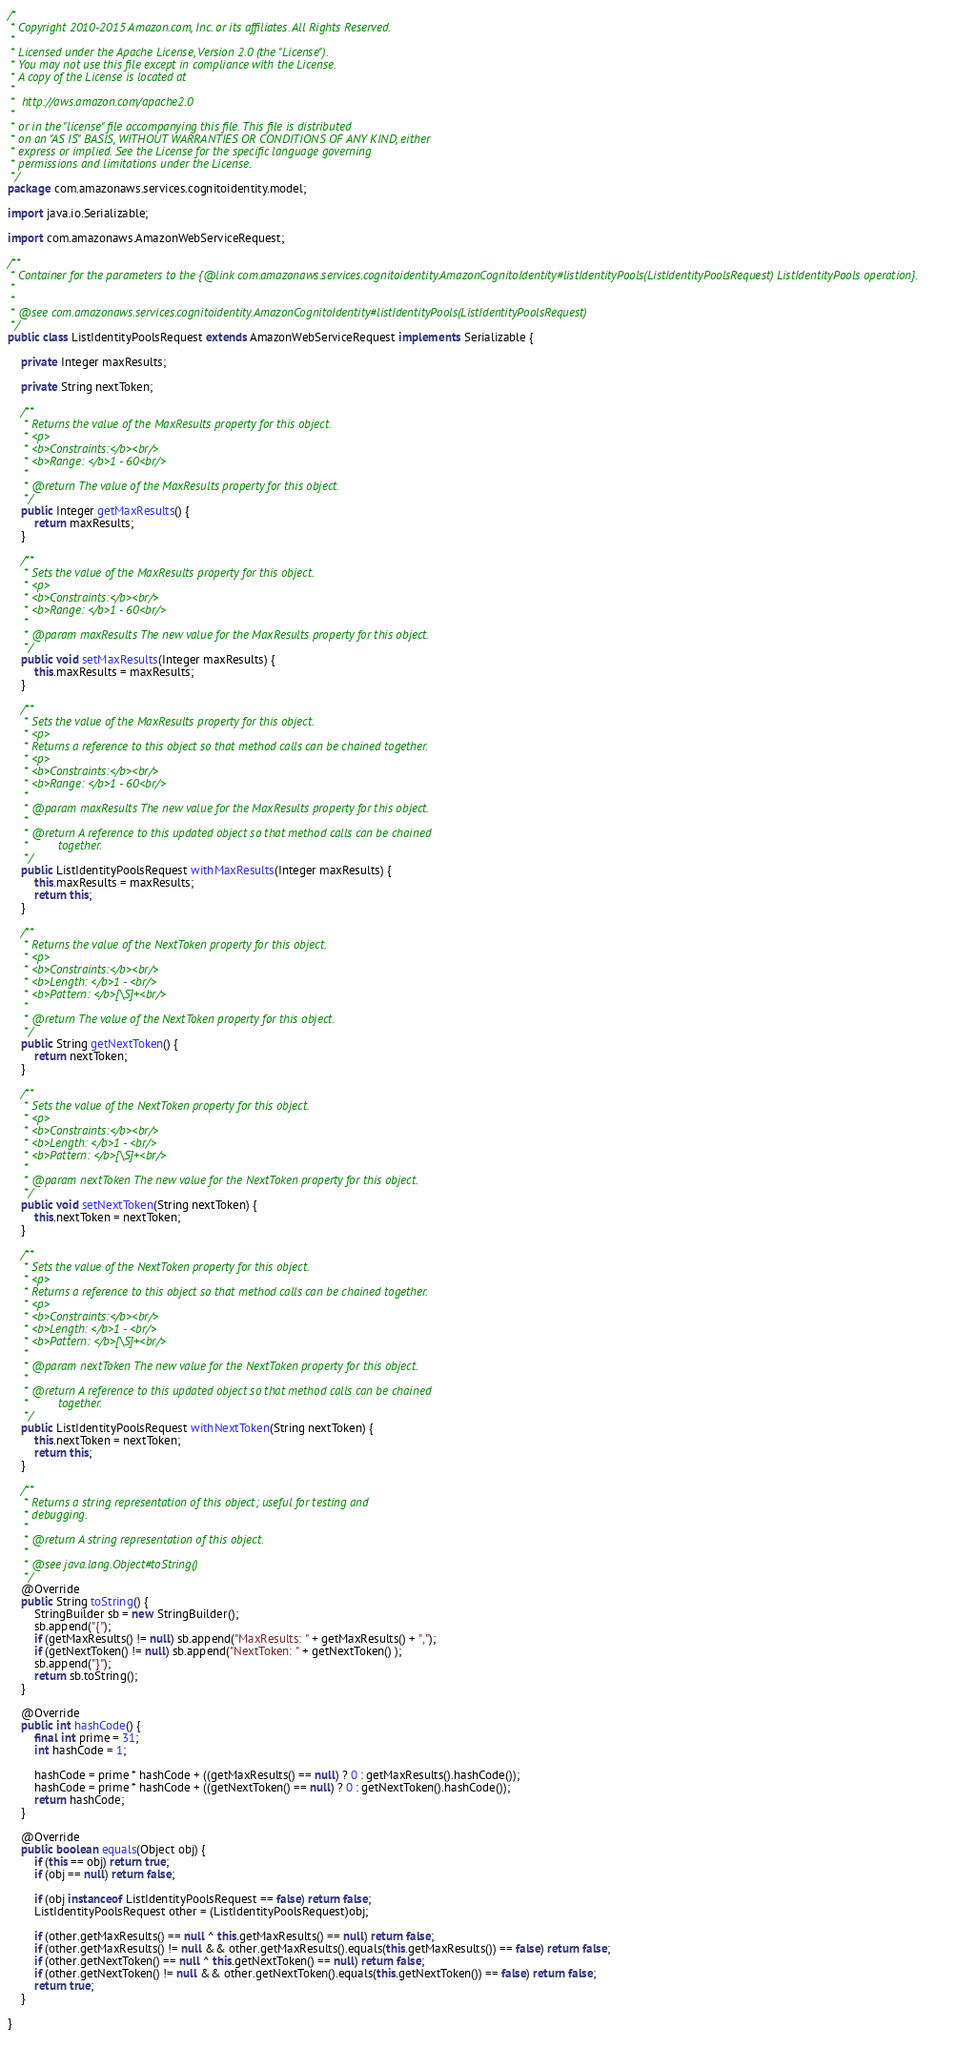Convert code to text. <code><loc_0><loc_0><loc_500><loc_500><_Java_>/*
 * Copyright 2010-2015 Amazon.com, Inc. or its affiliates. All Rights Reserved.
 * 
 * Licensed under the Apache License, Version 2.0 (the "License").
 * You may not use this file except in compliance with the License.
 * A copy of the License is located at
 * 
 *  http://aws.amazon.com/apache2.0
 * 
 * or in the "license" file accompanying this file. This file is distributed
 * on an "AS IS" BASIS, WITHOUT WARRANTIES OR CONDITIONS OF ANY KIND, either
 * express or implied. See the License for the specific language governing
 * permissions and limitations under the License.
 */
package com.amazonaws.services.cognitoidentity.model;

import java.io.Serializable;

import com.amazonaws.AmazonWebServiceRequest;

/**
 * Container for the parameters to the {@link com.amazonaws.services.cognitoidentity.AmazonCognitoIdentity#listIdentityPools(ListIdentityPoolsRequest) ListIdentityPools operation}.
 * 
 *
 * @see com.amazonaws.services.cognitoidentity.AmazonCognitoIdentity#listIdentityPools(ListIdentityPoolsRequest)
 */
public class ListIdentityPoolsRequest extends AmazonWebServiceRequest implements Serializable {

    private Integer maxResults;

    private String nextToken;

    /**
     * Returns the value of the MaxResults property for this object.
     * <p>
     * <b>Constraints:</b><br/>
     * <b>Range: </b>1 - 60<br/>
     *
     * @return The value of the MaxResults property for this object.
     */
    public Integer getMaxResults() {
        return maxResults;
    }
    
    /**
     * Sets the value of the MaxResults property for this object.
     * <p>
     * <b>Constraints:</b><br/>
     * <b>Range: </b>1 - 60<br/>
     *
     * @param maxResults The new value for the MaxResults property for this object.
     */
    public void setMaxResults(Integer maxResults) {
        this.maxResults = maxResults;
    }
    
    /**
     * Sets the value of the MaxResults property for this object.
     * <p>
     * Returns a reference to this object so that method calls can be chained together.
     * <p>
     * <b>Constraints:</b><br/>
     * <b>Range: </b>1 - 60<br/>
     *
     * @param maxResults The new value for the MaxResults property for this object.
     *
     * @return A reference to this updated object so that method calls can be chained
     *         together.
     */
    public ListIdentityPoolsRequest withMaxResults(Integer maxResults) {
        this.maxResults = maxResults;
        return this;
    }

    /**
     * Returns the value of the NextToken property for this object.
     * <p>
     * <b>Constraints:</b><br/>
     * <b>Length: </b>1 - <br/>
     * <b>Pattern: </b>[\S]+<br/>
     *
     * @return The value of the NextToken property for this object.
     */
    public String getNextToken() {
        return nextToken;
    }
    
    /**
     * Sets the value of the NextToken property for this object.
     * <p>
     * <b>Constraints:</b><br/>
     * <b>Length: </b>1 - <br/>
     * <b>Pattern: </b>[\S]+<br/>
     *
     * @param nextToken The new value for the NextToken property for this object.
     */
    public void setNextToken(String nextToken) {
        this.nextToken = nextToken;
    }
    
    /**
     * Sets the value of the NextToken property for this object.
     * <p>
     * Returns a reference to this object so that method calls can be chained together.
     * <p>
     * <b>Constraints:</b><br/>
     * <b>Length: </b>1 - <br/>
     * <b>Pattern: </b>[\S]+<br/>
     *
     * @param nextToken The new value for the NextToken property for this object.
     *
     * @return A reference to this updated object so that method calls can be chained
     *         together.
     */
    public ListIdentityPoolsRequest withNextToken(String nextToken) {
        this.nextToken = nextToken;
        return this;
    }

    /**
     * Returns a string representation of this object; useful for testing and
     * debugging.
     *
     * @return A string representation of this object.
     *
     * @see java.lang.Object#toString()
     */
    @Override
    public String toString() {
        StringBuilder sb = new StringBuilder();
        sb.append("{");
        if (getMaxResults() != null) sb.append("MaxResults: " + getMaxResults() + ",");
        if (getNextToken() != null) sb.append("NextToken: " + getNextToken() );
        sb.append("}");
        return sb.toString();
    }
    
    @Override
    public int hashCode() {
        final int prime = 31;
        int hashCode = 1;
        
        hashCode = prime * hashCode + ((getMaxResults() == null) ? 0 : getMaxResults().hashCode()); 
        hashCode = prime * hashCode + ((getNextToken() == null) ? 0 : getNextToken().hashCode()); 
        return hashCode;
    }
    
    @Override
    public boolean equals(Object obj) {
        if (this == obj) return true;
        if (obj == null) return false;

        if (obj instanceof ListIdentityPoolsRequest == false) return false;
        ListIdentityPoolsRequest other = (ListIdentityPoolsRequest)obj;
        
        if (other.getMaxResults() == null ^ this.getMaxResults() == null) return false;
        if (other.getMaxResults() != null && other.getMaxResults().equals(this.getMaxResults()) == false) return false; 
        if (other.getNextToken() == null ^ this.getNextToken() == null) return false;
        if (other.getNextToken() != null && other.getNextToken().equals(this.getNextToken()) == false) return false; 
        return true;
    }
    
}
    </code> 